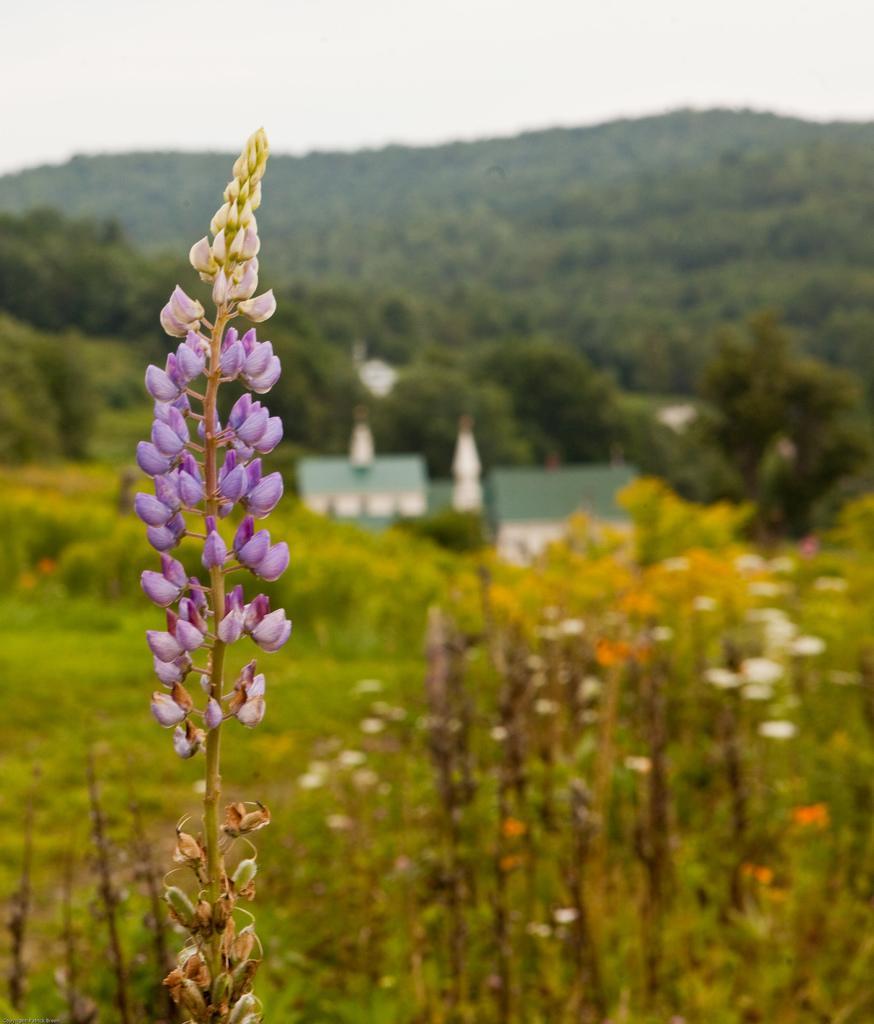Can you describe this image briefly? In the picture we can see some plants with a stem and some flowers in it and behind it, we can see many plants, trees, some houses and behind it, we can see hills which are covered with trees and on the top of it we can see the part of the sky. 